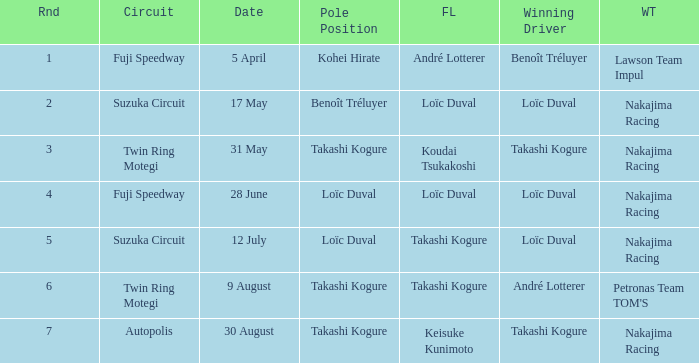Parse the full table. {'header': ['Rnd', 'Circuit', 'Date', 'Pole Position', 'FL', 'Winning Driver', 'WT'], 'rows': [['1', 'Fuji Speedway', '5 April', 'Kohei Hirate', 'André Lotterer', 'Benoît Tréluyer', 'Lawson Team Impul'], ['2', 'Suzuka Circuit', '17 May', 'Benoît Tréluyer', 'Loïc Duval', 'Loïc Duval', 'Nakajima Racing'], ['3', 'Twin Ring Motegi', '31 May', 'Takashi Kogure', 'Koudai Tsukakoshi', 'Takashi Kogure', 'Nakajima Racing'], ['4', 'Fuji Speedway', '28 June', 'Loïc Duval', 'Loïc Duval', 'Loïc Duval', 'Nakajima Racing'], ['5', 'Suzuka Circuit', '12 July', 'Loïc Duval', 'Takashi Kogure', 'Loïc Duval', 'Nakajima Racing'], ['6', 'Twin Ring Motegi', '9 August', 'Takashi Kogure', 'Takashi Kogure', 'André Lotterer', "Petronas Team TOM'S"], ['7', 'Autopolis', '30 August', 'Takashi Kogure', 'Keisuke Kunimoto', 'Takashi Kogure', 'Nakajima Racing']]} What was the earlier round where Takashi Kogure got the fastest lap? 5.0. 